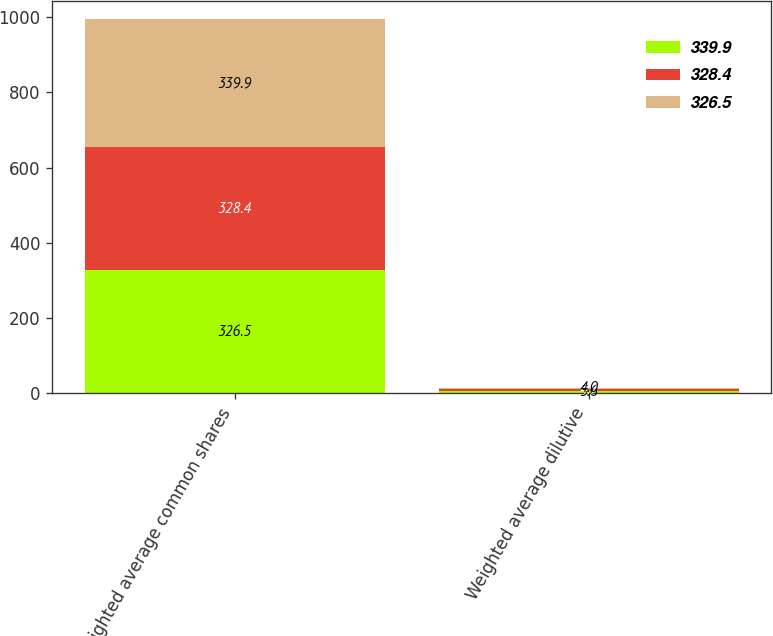Convert chart to OTSL. <chart><loc_0><loc_0><loc_500><loc_500><stacked_bar_chart><ecel><fcel>Weighted average common shares<fcel>Weighted average dilutive<nl><fcel>339.9<fcel>326.5<fcel>5.6<nl><fcel>328.4<fcel>328.4<fcel>4.7<nl><fcel>326.5<fcel>339.9<fcel>4<nl></chart> 